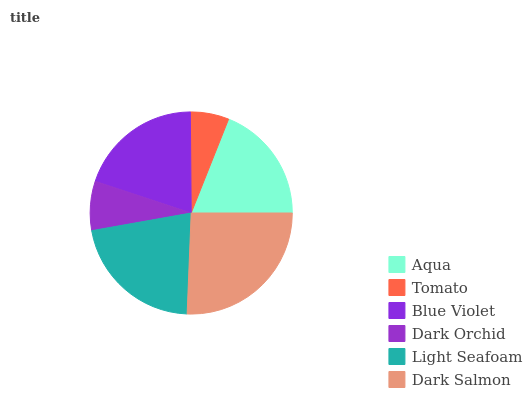Is Tomato the minimum?
Answer yes or no. Yes. Is Dark Salmon the maximum?
Answer yes or no. Yes. Is Blue Violet the minimum?
Answer yes or no. No. Is Blue Violet the maximum?
Answer yes or no. No. Is Blue Violet greater than Tomato?
Answer yes or no. Yes. Is Tomato less than Blue Violet?
Answer yes or no. Yes. Is Tomato greater than Blue Violet?
Answer yes or no. No. Is Blue Violet less than Tomato?
Answer yes or no. No. Is Blue Violet the high median?
Answer yes or no. Yes. Is Aqua the low median?
Answer yes or no. Yes. Is Light Seafoam the high median?
Answer yes or no. No. Is Tomato the low median?
Answer yes or no. No. 